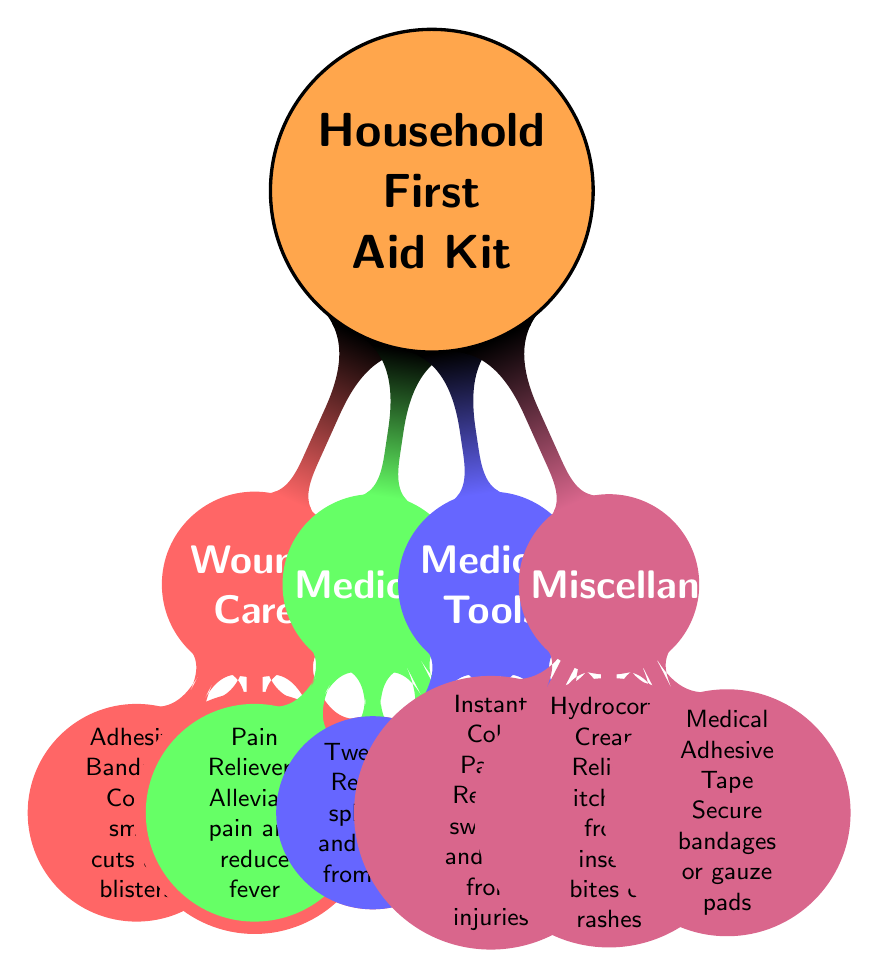What is the main topic of the diagram? The diagram is centered around the concept of a "Household First Aid Kit." This is indicated by the node at the center of the mind map, which serves as the main idea from which all other information branches out.
Answer: Household First Aid Kit How many categories are there under the Household First Aid Kit? The diagram features four main categories: Wound Care, Medications, Medical Tools, and Miscellaneous. These are the first-level child nodes branching out from the main concept.
Answer: 4 What item is used to clean and disinfect wounds? The diagram lists "Antiseptic Wipes" specifically under the Wound Care category. This is indicated in the branch that contains items for treating wounds, showing its purpose directly.
Answer: Antiseptic Wipes Which item measures body temperature? Within the Medical Tools category, the "Digital Thermometer" is designated for measuring body temperature, as shown in the corresponding branch of the diagram.
Answer: Digital Thermometer What is the purpose of Hydrocortisone Cream? The diagram states that Hydrocortisone Cream is used to "Relieve itching from insect bites or rashes." This information is provided within the Miscellaneous section of the diagram.
Answer: Relieve itching from insect bites or rashes Which item would you use to remove splinters? According to the Medical Tools category, "Tweezers" are specifically mentioned for the purpose of removing splinters and debris from the skin, as indicated in that particular branch.
Answer: Tweezers How many items are listed under Wound Care? The Wound Care category lists three items: Adhesive Bandages, Sterile Gauze Pads, and Antiseptic Wipes. By counting each of these distinct elements, we find the total number.
Answer: 3 Which category includes Pain Relievers? The item "Pain Relievers" appears under the Medications category, as clearly indicated by the diagram’s layout which organizes items by their respective functionalities.
Answer: Medications What function do Instant Cold Packs serve? Instant Cold Packs are detailed in the Miscellaneous section with the specific purpose of "Reduce swelling and pain from injuries," describing their utility in first aid scenarios.
Answer: Reduce swelling and pain from injuries 